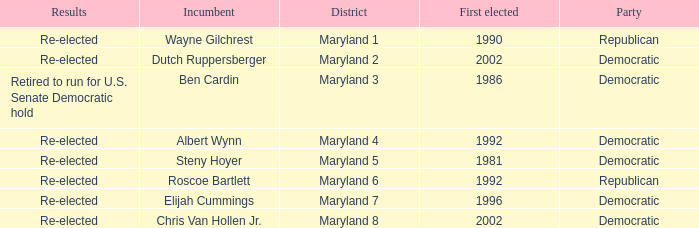What are the results of the incumbent who was first elected in 1996? Re-elected. Can you give me this table as a dict? {'header': ['Results', 'Incumbent', 'District', 'First elected', 'Party'], 'rows': [['Re-elected', 'Wayne Gilchrest', 'Maryland 1', '1990', 'Republican'], ['Re-elected', 'Dutch Ruppersberger', 'Maryland 2', '2002', 'Democratic'], ['Retired to run for U.S. Senate Democratic hold', 'Ben Cardin', 'Maryland 3', '1986', 'Democratic'], ['Re-elected', 'Albert Wynn', 'Maryland 4', '1992', 'Democratic'], ['Re-elected', 'Steny Hoyer', 'Maryland 5', '1981', 'Democratic'], ['Re-elected', 'Roscoe Bartlett', 'Maryland 6', '1992', 'Republican'], ['Re-elected', 'Elijah Cummings', 'Maryland 7', '1996', 'Democratic'], ['Re-elected', 'Chris Van Hollen Jr.', 'Maryland 8', '2002', 'Democratic']]} 